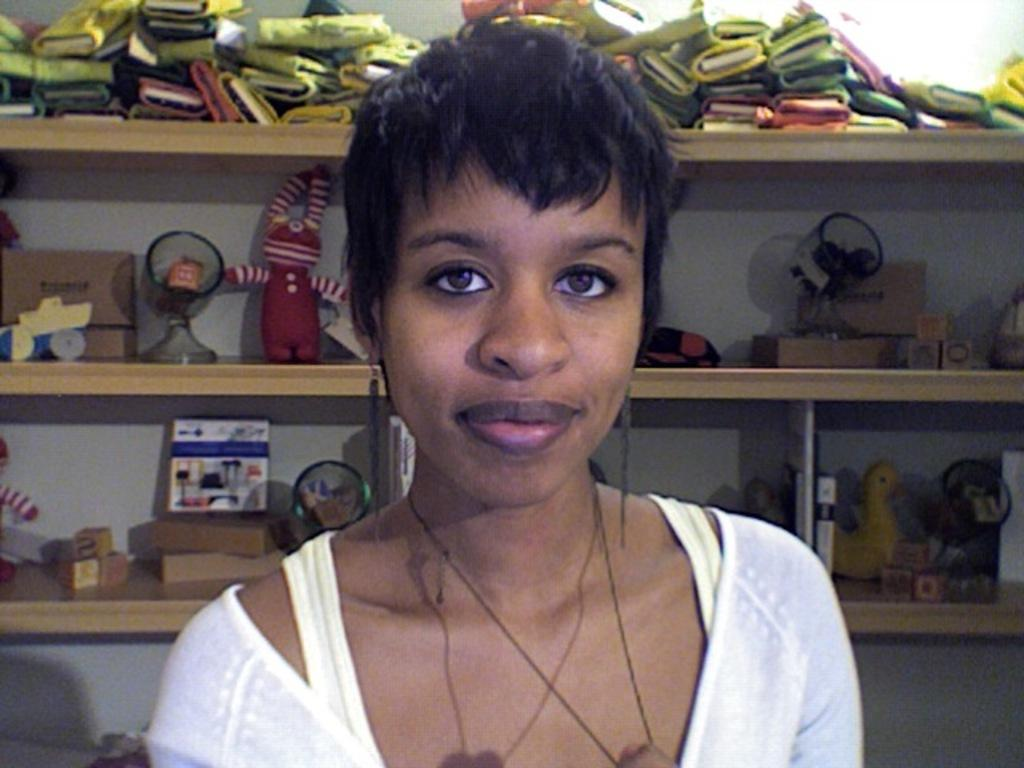Who is the main subject in the image? There is a lady in the center of the image. What can be seen in the background of the image? There are toys, blocks, and other objects on shelves in the background of the image. What is the background setting of the image? There is a wall in the background of the image. How many trucks are parked in front of the lady in the image? There are no trucks present in the image. What type of lock is securing the blocks in the image? There is no lock present in the image; the blocks are simply placed on the floor or shelves. 